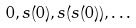Convert formula to latex. <formula><loc_0><loc_0><loc_500><loc_500>0 , s ( 0 ) , s ( s ( 0 ) ) , \dots</formula> 